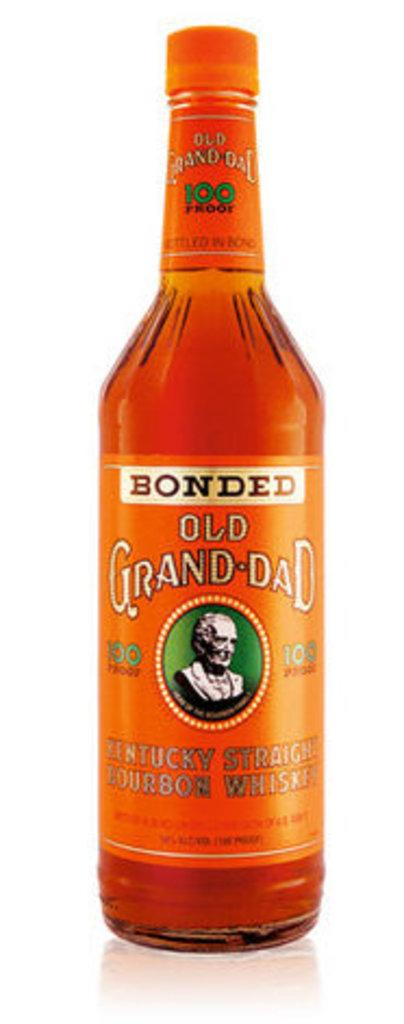Provide a one-sentence caption for the provided image. A bottle of Bonded Old Grand-Dad has a picture of a statue bust on it. 